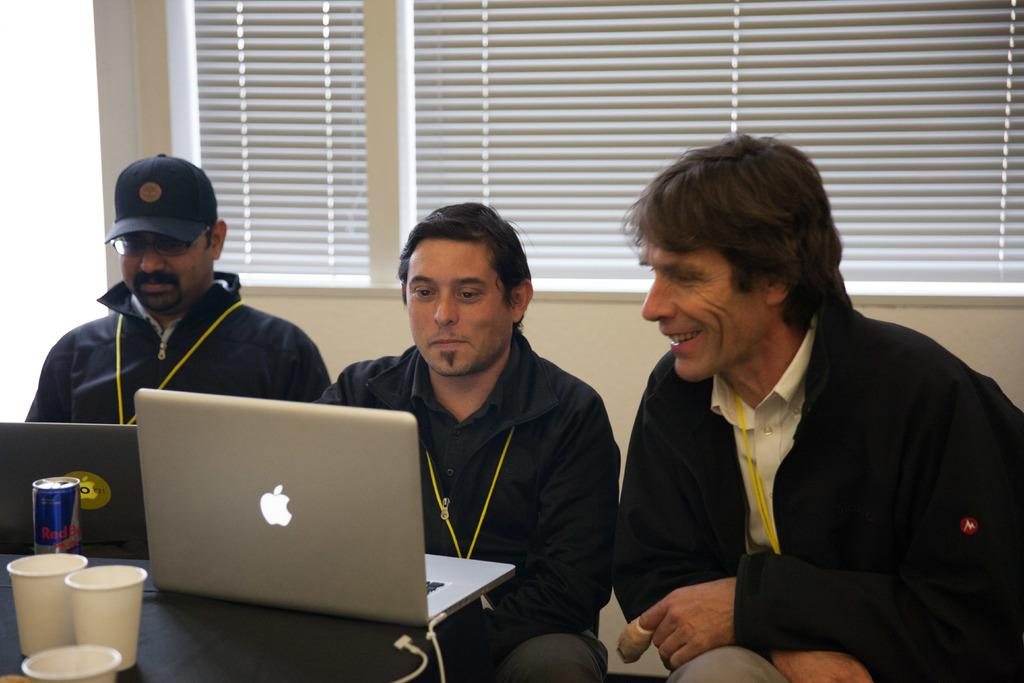How many men are sitting in the image? There are three men sitting in the image. What objects are on the table in the image? There are laptops, cups, a tin, and a cable on the table in the image. What can be seen in the background of the image? There is a wall and a window blind in the background. What type of bubble can be seen in the image? There is no bubble present in the image. What punishment are the men receiving in the image? There is no indication of punishment in the image; the men are simply sitting at a table with various objects. 